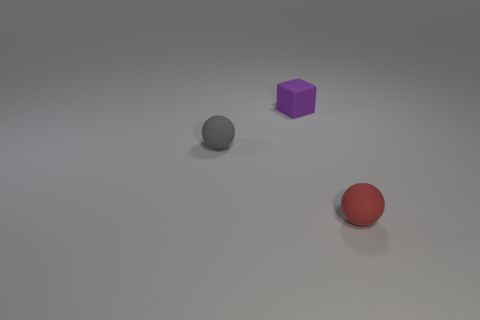What colors are the objects in the image? In the image presented, there are three objects, each with its unique color. The sphere closest to the viewer is red, the cube in the middle is purple, and the sphere at the farthest point is grey. 